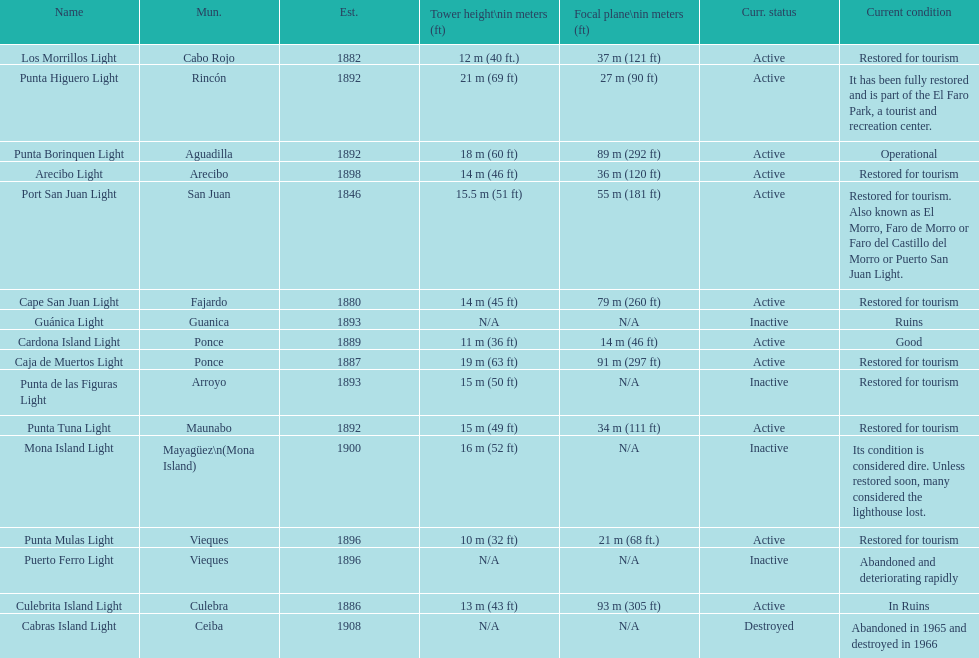How many establishments are restored for tourism? 9. 